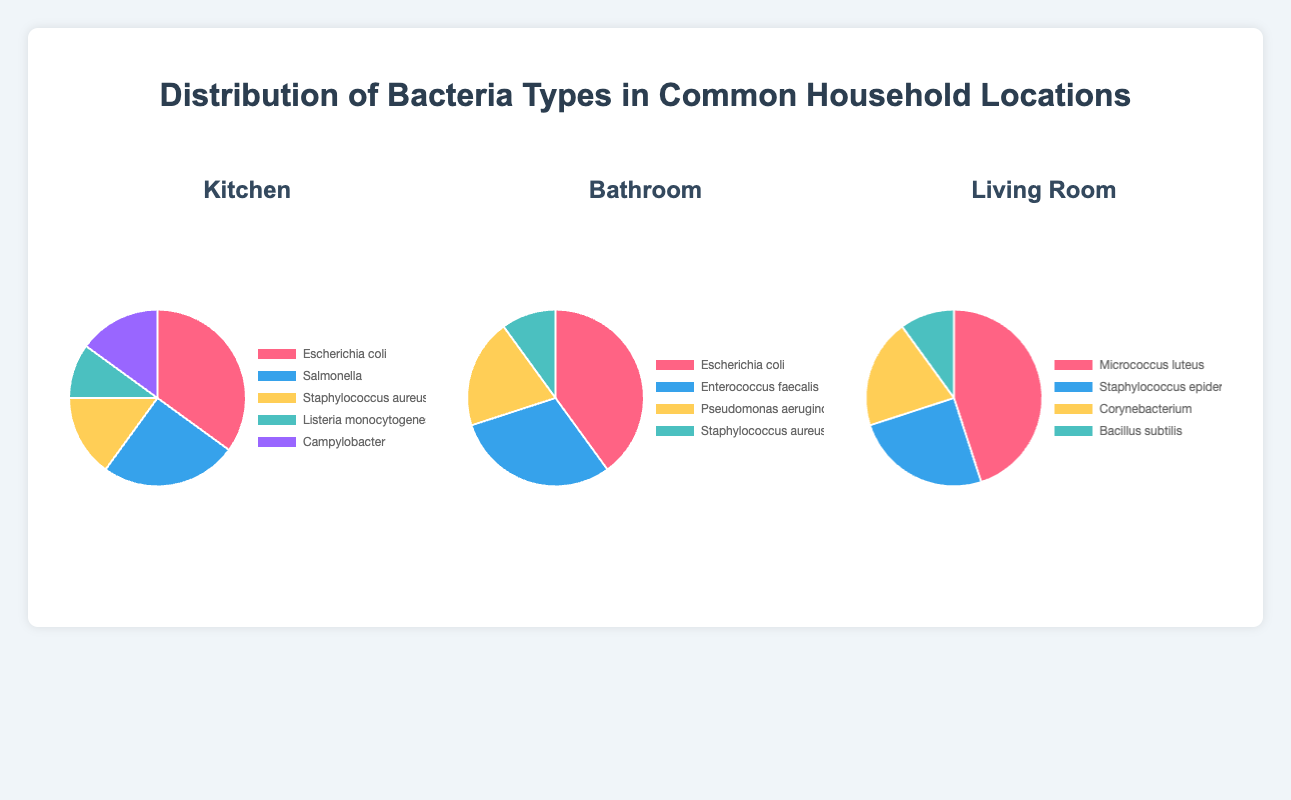Which location has the highest percentage of Escherichia coli? By looking at the three pie charts, check the percentages of Escherichia coli. Kitchen has 35%, Bathroom has 40%, and Living Room has 0%. Therefore, the Bathroom has the highest percentage.
Answer: Bathroom Which bacteria type occupies the largest portion in the Living Room? Observe the pie chart for the Living Room and see which bacteria type has the largest slice. Micrococcus luteus has the largest percentage of 45%.
Answer: Micrococcus luteus How much greater is the percentage of Enterococcus faecalis in the Bathroom compared to Listeria monocytogenes in the Kitchen? Find the percentages of Enterococcus faecalis in the Bathroom (30%) and Listeria monocytogenes in the Kitchen (10%). The difference is 30% - 10% = 20%.
Answer: 20% What is the combined percentage of Staphylococcus aureus in the Kitchen and Bathroom? Check the percentage of Staphylococcus aureus in both locations: 15% in the Kitchen and 10% in the Bathroom. Add them together: 15% + 10% = 25%.
Answer: 25% Which bacteria type is represented by the green segment in the Kitchen chart? Examine the Kitchen pie chart and locate the green segment. The green segment corresponds to Staphylococcus aureus at 15%.
Answer: Staphylococcus aureus In which location does Campylobacter appear, and what is its percentage? Scan through each pie chart. Campylobacter appears in the Kitchen, with a percentage of 15%.
Answer: Kitchen, 15% Is the percentage of Staphylococcus epidermidis in the Living Room greater than or less than the percentage of Pseudomonas aeruginosa in the Bathroom? Look at the percentages: Staphylococcus epidermidis in the Living Room (25%) and Pseudomonas aeruginosa in the Bathroom (20%). 25% is greater than 20%.
Answer: Greater than What is the difference in percentage between the largest and smallest bacteria type in the Living Room? Identify the largest (Micrococcus luteus, 45%) and the smallest (Bacillus subtilis, 10%) bacteria types in the Living Room. The difference is 45% - 10% = 35%.
Answer: 35% Which location has more diversity in the types of bacteria represented in the pie chart? Count the unique bacteria types in each pie chart. The Kitchen and Bathroom each have 5 types, while the Living Room has 4 types. Kitchen and Bathroom both have the highest diversity.
Answer: Kitchen and Bathroom 